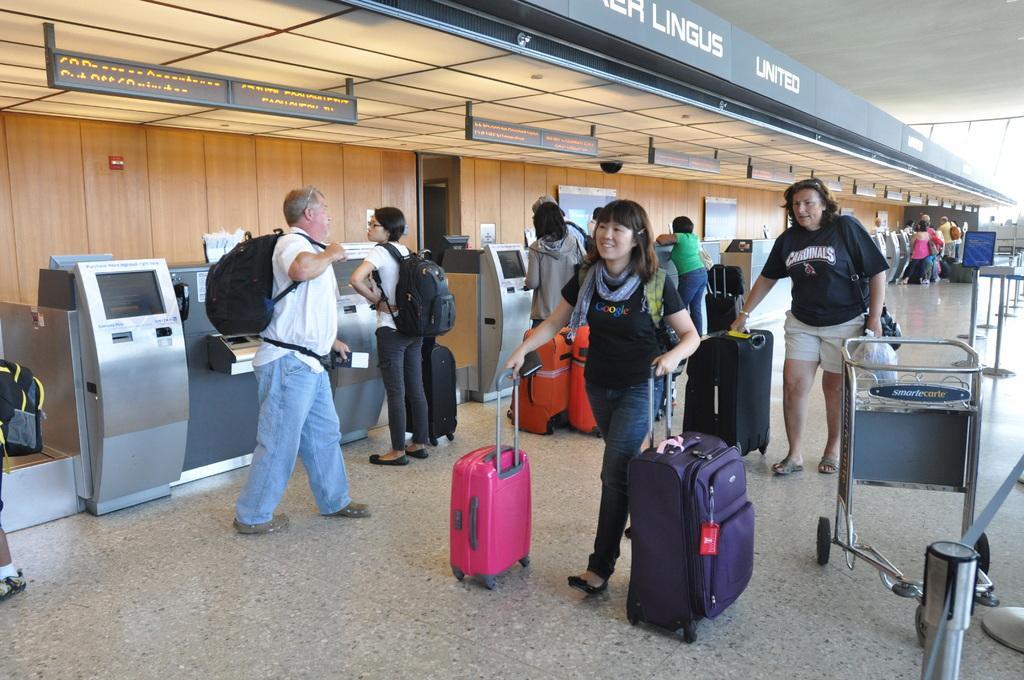How would you summarize this image in a sentence or two? people are walking in airport. the person at the front is wearing a black t shirt and walking. she is holding a pink and a purple briefcase in her hands. behind her a person is wearing a black t shirt and cream shorts is carrying a black briefcase. at the left people are standing wearing black backpacks. at the left there are machines. on the top there are hoardings. above that on the hoarding on which united is written. 